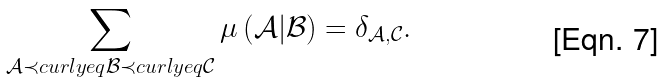Convert formula to latex. <formula><loc_0><loc_0><loc_500><loc_500>\sum _ { \mathcal { A } \prec c u r l y e q \mathcal { B } \prec c u r l y e q \mathcal { C } } \mu \left ( \mathcal { A } | \mathcal { B } \right ) = \delta _ { \mathcal { A } , \mathcal { C } } .</formula> 